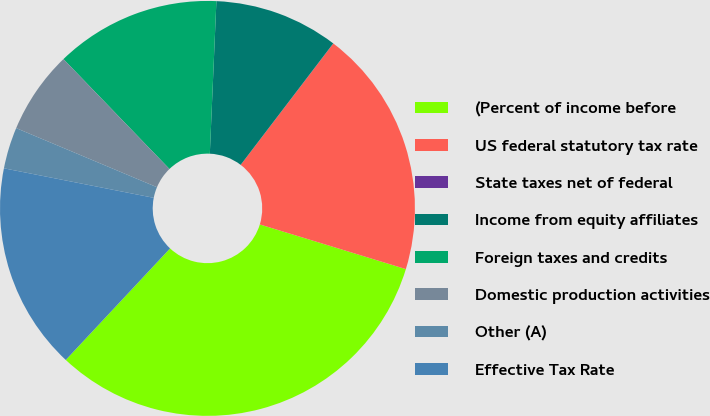<chart> <loc_0><loc_0><loc_500><loc_500><pie_chart><fcel>(Percent of income before<fcel>US federal statutory tax rate<fcel>State taxes net of federal<fcel>Income from equity affiliates<fcel>Foreign taxes and credits<fcel>Domestic production activities<fcel>Other (A)<fcel>Effective Tax Rate<nl><fcel>32.24%<fcel>19.35%<fcel>0.01%<fcel>9.68%<fcel>12.9%<fcel>6.46%<fcel>3.23%<fcel>16.13%<nl></chart> 